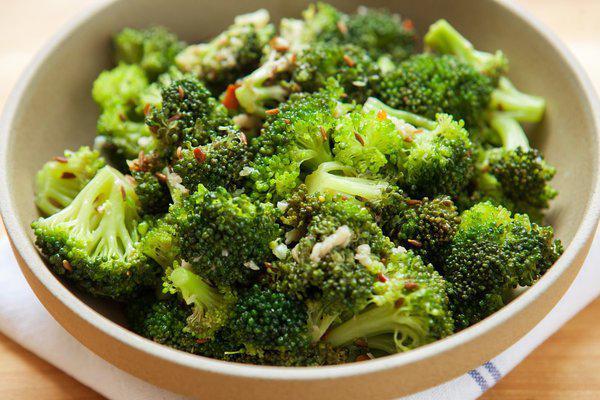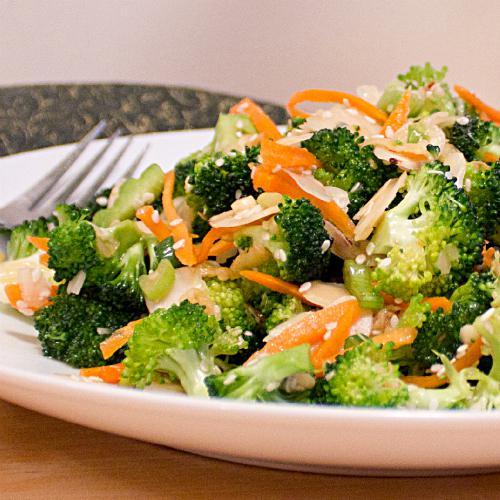The first image is the image on the left, the second image is the image on the right. Evaluate the accuracy of this statement regarding the images: "The left and right image contains the same number of white bowls full of broccoli.". Is it true? Answer yes or no. Yes. The first image is the image on the left, the second image is the image on the right. Examine the images to the left and right. Is the description "One image shows a piece of silverware on the edge of a round white handle-less dish containing broccoli florets." accurate? Answer yes or no. Yes. 